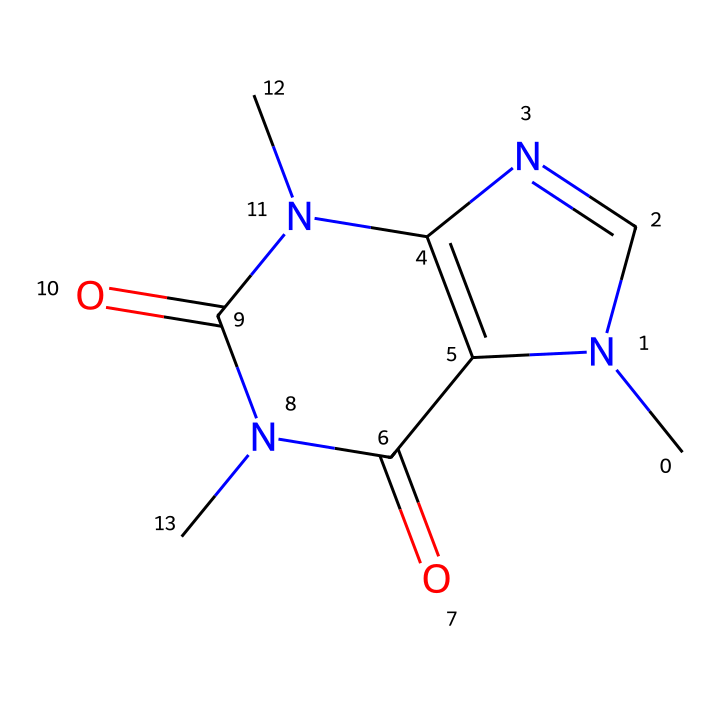What is the molecular formula of caffeine? The molecular formula can be derived from the structure. By counting the individual atoms present, we find there are 8 carbon atoms, 10 hydrogen atoms, 4 nitrogen atoms, and 2 oxygen atoms. Thus, the molecular formula is C8H10N4O2.
Answer: C8H10N4O2 How many nitrogen atoms are in caffeine? In the provided structure, we can visually count the nitrogen atoms, which appear as 'N' in the molecule. There are a total of 4 nitrogen atoms present in the chemical structure.
Answer: 4 What type of organic compound is caffeine classified as? Caffeine is classified as an alkaloid because it contains nitrogen and has physiological effects, commonly found in plants. The presence of multiple nitrogen atoms supports this classification.
Answer: alkaloid How many rings are present in the caffeine structure? The structure shows two interconnected ring systems, which can be identified by the cyclic arrangement of the carbon and nitrogen atoms. Therefore, there are 2 rings in caffeine.
Answer: 2 Which functional groups can be identified in caffeine? The structure contains multiple carbonyl groups (C=O), indicated by the double bonds to oxygen atoms, and the nitrogen atoms suggest that it also features amine groups (N). Therefore, the functional groups present are carbonyl and amine groups.
Answer: carbonyl and amine What is the significance of the carbonyl groups in caffeine? The carbonyl groups are significant because they contribute to the overall polarity of the molecule, affecting its solubility and physiological activity. The presence of these functional groups can influence how caffeine interacts with biological receptors in the body.
Answer: polarity What is the total number of atoms in caffeine? To determine the total number of atoms, you sum the individual counts of carbon, hydrogen, nitrogen, and oxygen. Counting gives us 8 (C) + 10 (H) + 4 (N) + 2 (O) = 24 atoms in total in the caffeine molecule.
Answer: 24 